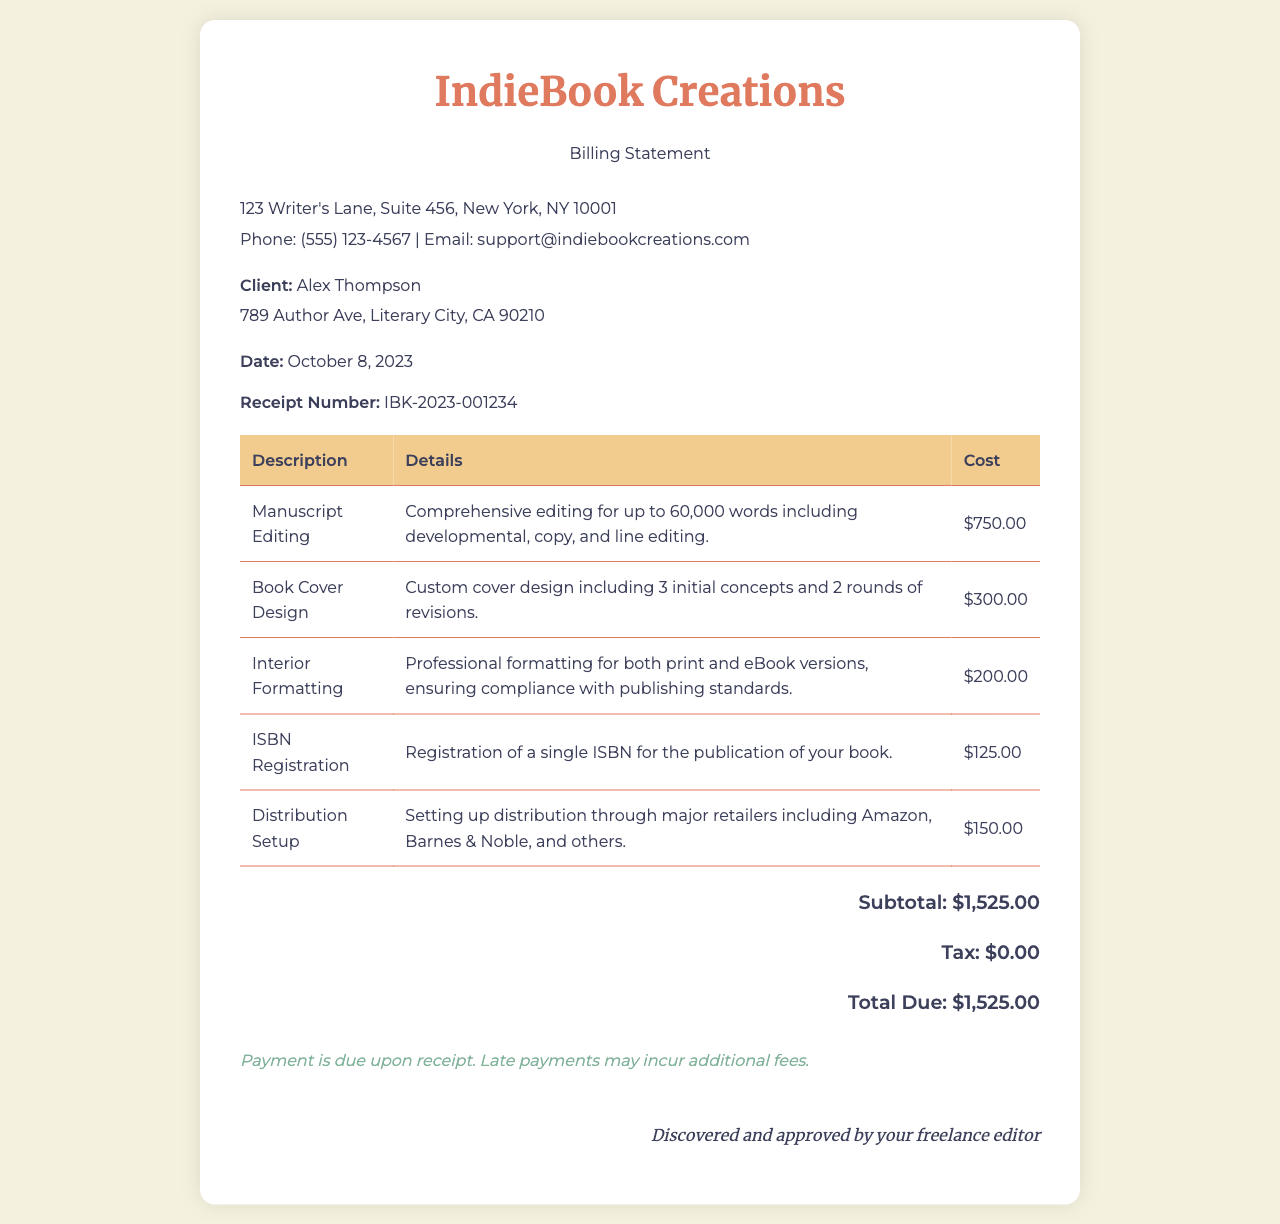What is the client's name? The client's name is mentioned in the document as "Alex Thompson".
Answer: Alex Thompson What is the total due amount? The total due amount is clearly stated in the document under the total section as "$1,525.00".
Answer: $1,525.00 What date was the receipt issued? The issue date of the receipt is provided in the document as "October 8, 2023".
Answer: October 8, 2023 How much is charged for ISBN registration? The document specifies the cost for ISBN registration as "$125.00".
Answer: $125.00 What is included in the manuscript editing services? The document details that manuscript editing includes "developmental, copy, and line editing".
Answer: developmental, copy, and line editing What is the subtotal amount? The subtotal amount before tax is listed in the document as "$1,525.00".
Answer: $1,525.00 Who is the service provider? The service provider's name is given at the top of the document as "IndieBook Creations".
Answer: IndieBook Creations Is tax included in the total due? The document explicitly states that the tax amount is "$0.00", indicating no tax is added to the total.
Answer: $0.00 What is the purpose of the payment terms section? The payment terms section outlines conditions for payment, stating that "Payment is due upon receipt."
Answer: Payment is due upon receipt 